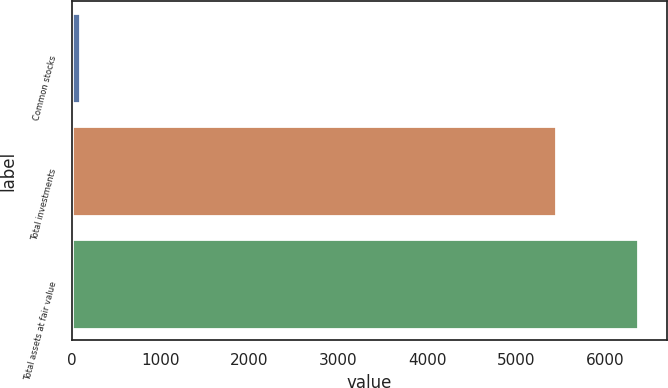Convert chart. <chart><loc_0><loc_0><loc_500><loc_500><bar_chart><fcel>Common stocks<fcel>Total investments<fcel>Total assets at fair value<nl><fcel>90<fcel>5444<fcel>6372<nl></chart> 